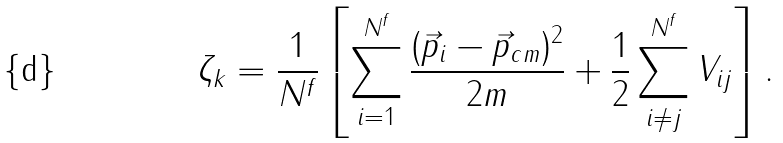<formula> <loc_0><loc_0><loc_500><loc_500>\zeta _ { k } = \frac { 1 } { N ^ { f } } \left [ \sum _ { i = 1 } ^ { N ^ { f } } \frac { ( \vec { p } _ { i } - \vec { p } _ { c m } ) ^ { 2 } } { 2 m } + \frac { 1 } { 2 } \sum _ { i \ne j } ^ { N ^ { f } } V _ { i j } \right ] .</formula> 